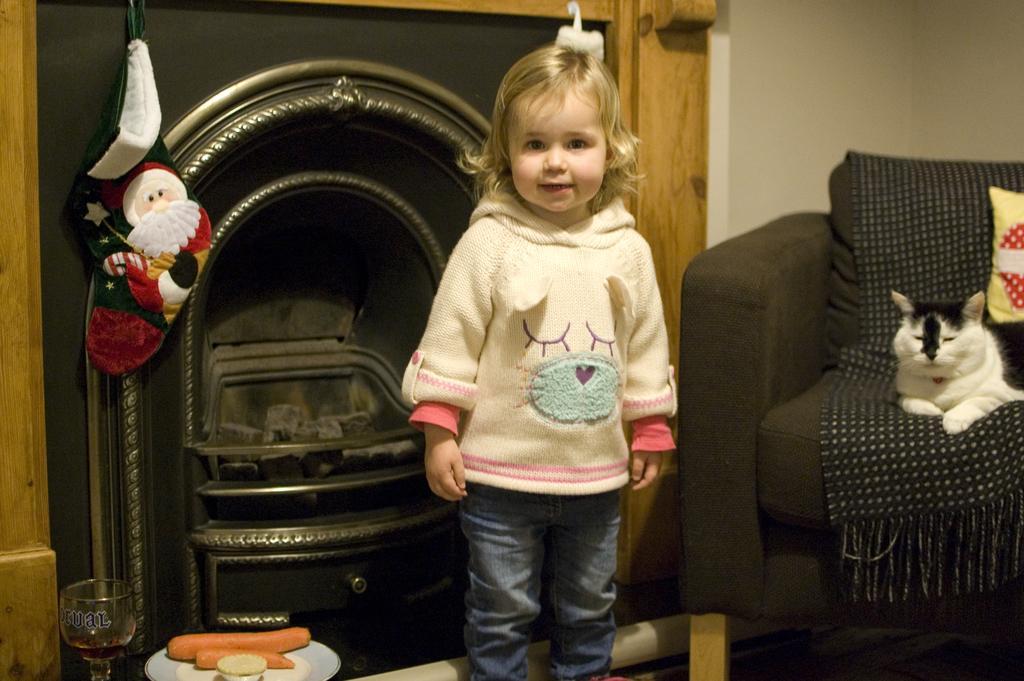Describe this image in one or two sentences. In this picture there is a girl standing. There is a chair, pillow and a cat. There is a glass. There are carrots in the plate and a bowl. 